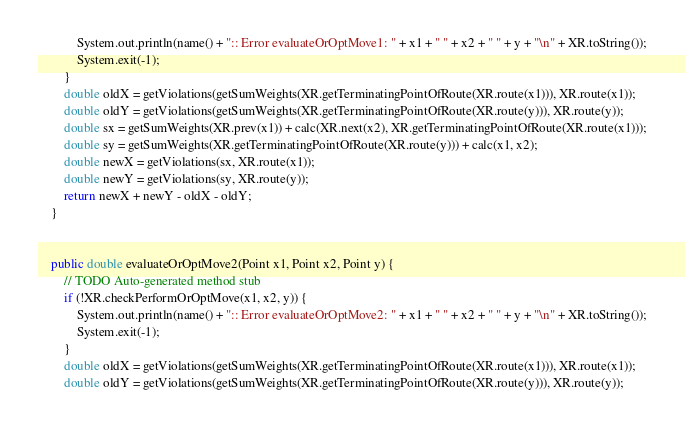<code> <loc_0><loc_0><loc_500><loc_500><_Java_>			System.out.println(name() + ":: Error evaluateOrOptMove1: " + x1 + " " + x2 + " " + y + "\n" + XR.toString());
    		System.exit(-1);
		}
		double oldX = getViolations(getSumWeights(XR.getTerminatingPointOfRoute(XR.route(x1))), XR.route(x1));
        double oldY = getViolations(getSumWeights(XR.getTerminatingPointOfRoute(XR.route(y))), XR.route(y));
        double sx = getSumWeights(XR.prev(x1)) + calc(XR.next(x2), XR.getTerminatingPointOfRoute(XR.route(x1)));
        double sy = getSumWeights(XR.getTerminatingPointOfRoute(XR.route(y))) + calc(x1, x2);
        double newX = getViolations(sx, XR.route(x1));
        double newY = getViolations(sy, XR.route(y));
		return newX + newY - oldX - oldY;
	}

	
	public double evaluateOrOptMove2(Point x1, Point x2, Point y) {
		// TODO Auto-generated method stub
		if (!XR.checkPerformOrOptMove(x1, x2, y)) {
			System.out.println(name() + ":: Error evaluateOrOptMove2: " + x1 + " " + x2 + " " + y + "\n" + XR.toString());
    		System.exit(-1);
		}
		double oldX = getViolations(getSumWeights(XR.getTerminatingPointOfRoute(XR.route(x1))), XR.route(x1));
        double oldY = getViolations(getSumWeights(XR.getTerminatingPointOfRoute(XR.route(y))), XR.route(y));</code> 